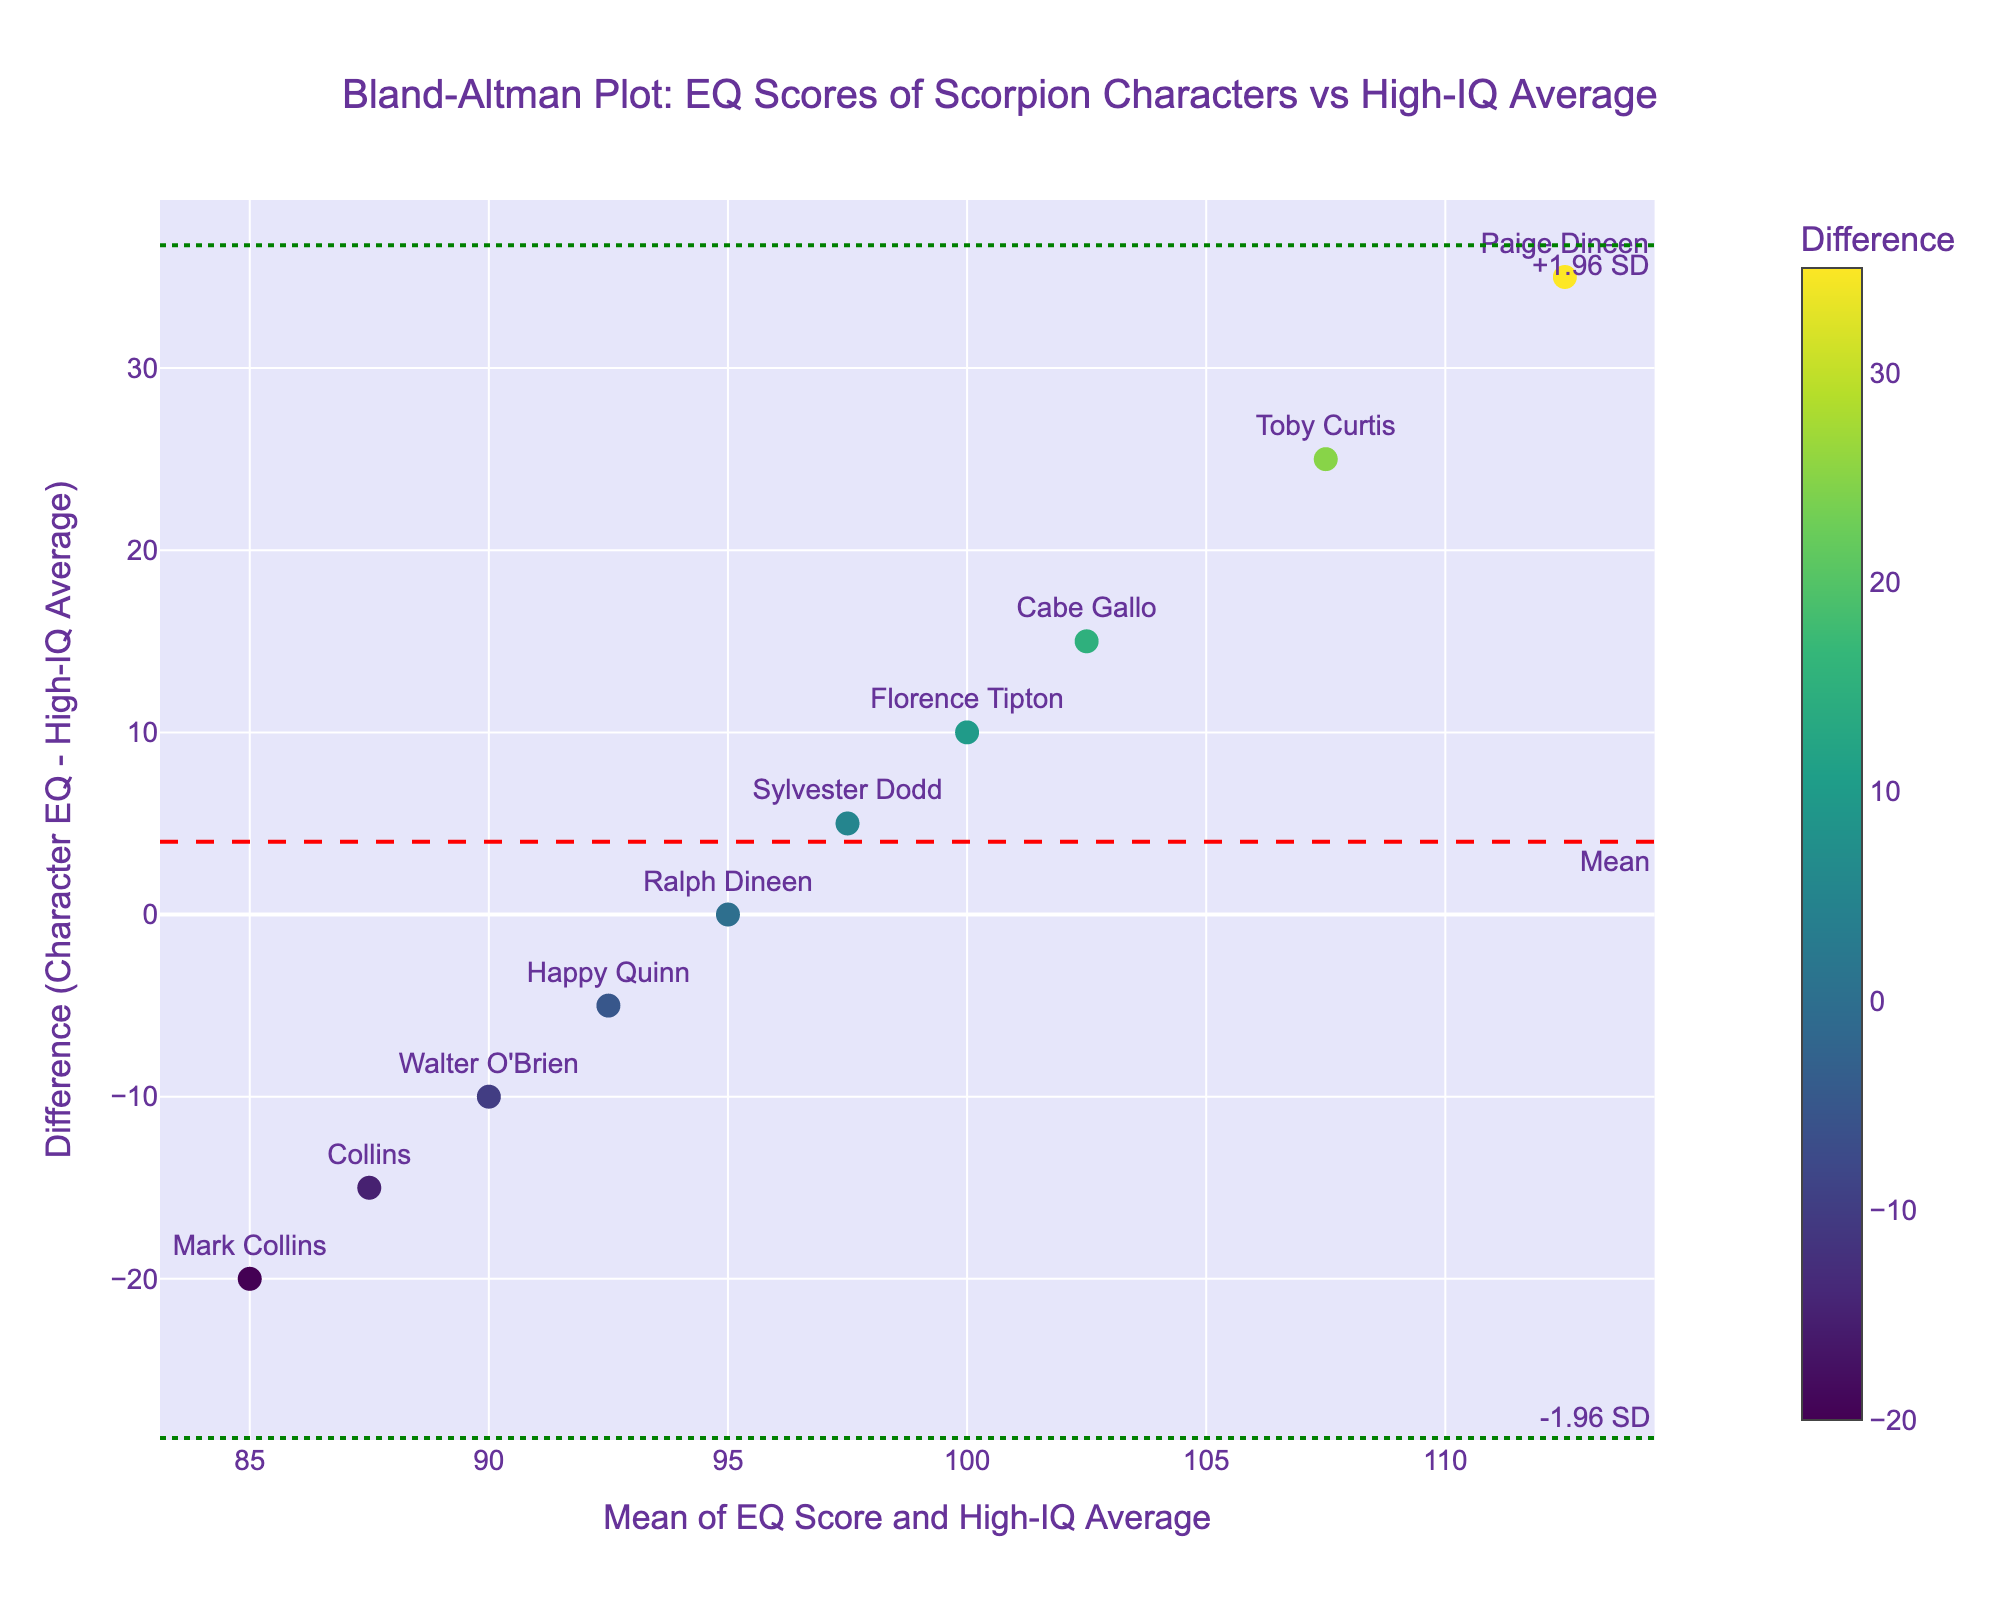What is the title of the figure? The title of the figure is typically displayed at the top and indicates the content of the plot. Here, it reads "Bland-Altman Plot: EQ Scores of Scorpion Characters vs High-IQ Average"
Answer: Bland-Altman Plot: EQ Scores of Scorpion Characters vs High-IQ Average How many characters have an EQ score higher than the high-IQ average? The EQ scores that exceed the high-IQ average are above the zero difference line. The characters above this line are Toby Curtis, Sylvester Dodd, Paige Dineen, Cabe Gallo, and Florence Tipton.
Answer: 5 What is the mean difference in EQ scores between the Scorpion characters and typical high-IQ individuals? The mean difference is usually indicated by a reference line in the Bland-Altman plot. It's calculated as the average of all differences. The mean difference line is labeled "Mean" and is located at the y-position shown in the figure.
Answer: Mean difference is -2.5 Which character has the highest positive difference in EQ score? To find the highest positive difference, look for the highest point above the zero line. Paige Dineen has the highest positive difference.
Answer: Paige Dineen What is the range of values for the limits of agreement in the plot? The limits of agreement are calculated as the mean difference ± 1.96 times the standard deviation of the differences. These are marked by green dash-dot lines in the plot. The lower limit is the line marked "-1.96 SD" and the upper limit is marked "+1.96 SD".
Answer: -29.77 to 24.77 Which character has the lowest EQ score, and what is its difference with the high-IQ average? The lowest EQ score corresponds to the lowest difference point on the plot. Mark Collins has the lowest EQ score, which is a difference of -20.
Answer: Mark Collins, -20 What is the mean of EQ Score and High-IQ Average for Toby Curtis? The mean for Toby Curtis can be found on the horizontal axis, where his marker is located. It is calculated as the average of his EQ score and the high-IQ average. (120 + 95) / 2 = 107.5
Answer: 107.5 Are there more characters above or below the mean difference line? To determine this, count the markers above and below the line labeled "Mean". The mean difference line splits the differences evenly or unevenly. There are 5 above and 5 below.
Answer: Equal (5 above, 5 below) What can be inferred about the variation in EQ scores among the Scorpion characters compared to the high-IQ average? By inspecting the dispersion of the data points around the mean difference line and within the limits of agreement, one can infer the degree of variation in EQ scores. The variability is showcased by how spread out or concentrated the points are.
Answer: Scorpion characters have varied EQ scores with both higher and lower extremes compared to high-IQ individuals How does Cabe Gallo's EQ score compare to the high-IQ average, and what does it mean on the plot? To compare Cabe Gallo's EQ score, locate his marker on the plot. His difference from the high-IQ average and his mean EQ can be determined. Cabe Gallo’s EQ score is higher than the high-IQ average, with a difference of 15.
Answer: Higher, Difference +15 